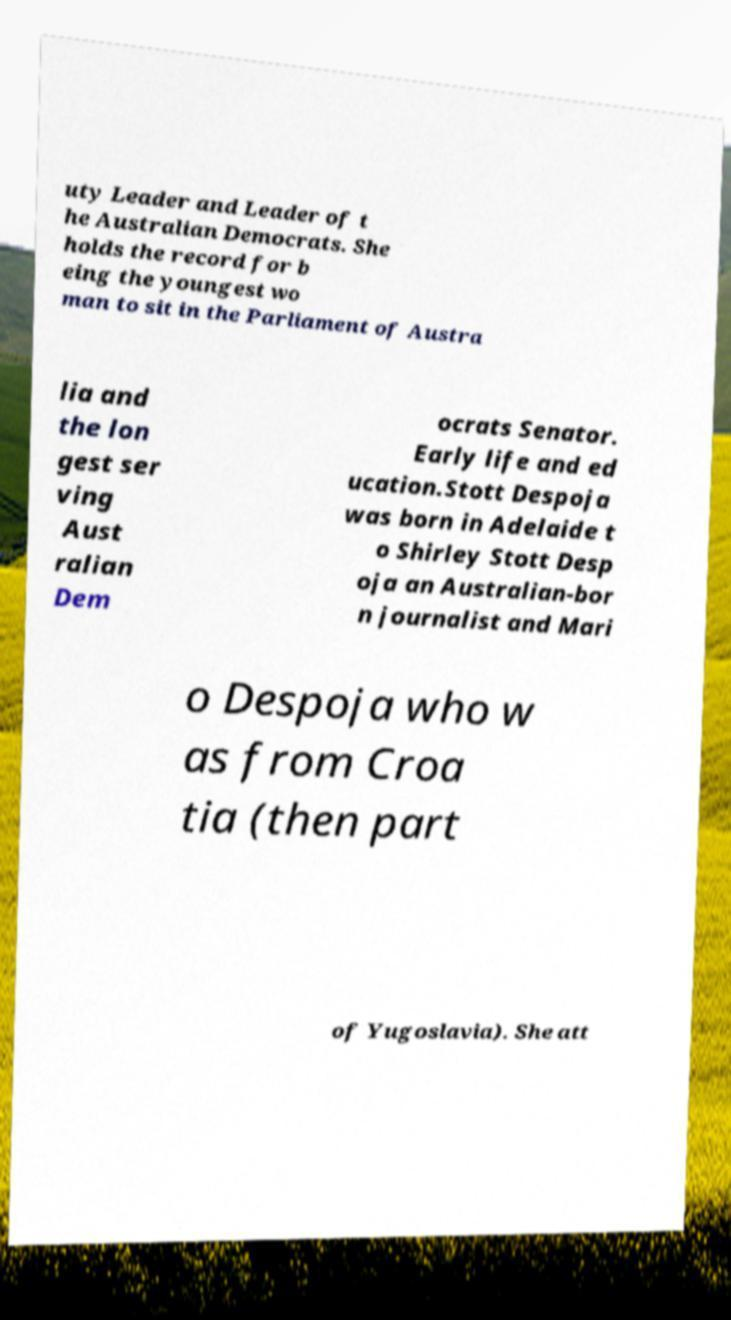For documentation purposes, I need the text within this image transcribed. Could you provide that? uty Leader and Leader of t he Australian Democrats. She holds the record for b eing the youngest wo man to sit in the Parliament of Austra lia and the lon gest ser ving Aust ralian Dem ocrats Senator. Early life and ed ucation.Stott Despoja was born in Adelaide t o Shirley Stott Desp oja an Australian-bor n journalist and Mari o Despoja who w as from Croa tia (then part of Yugoslavia). She att 